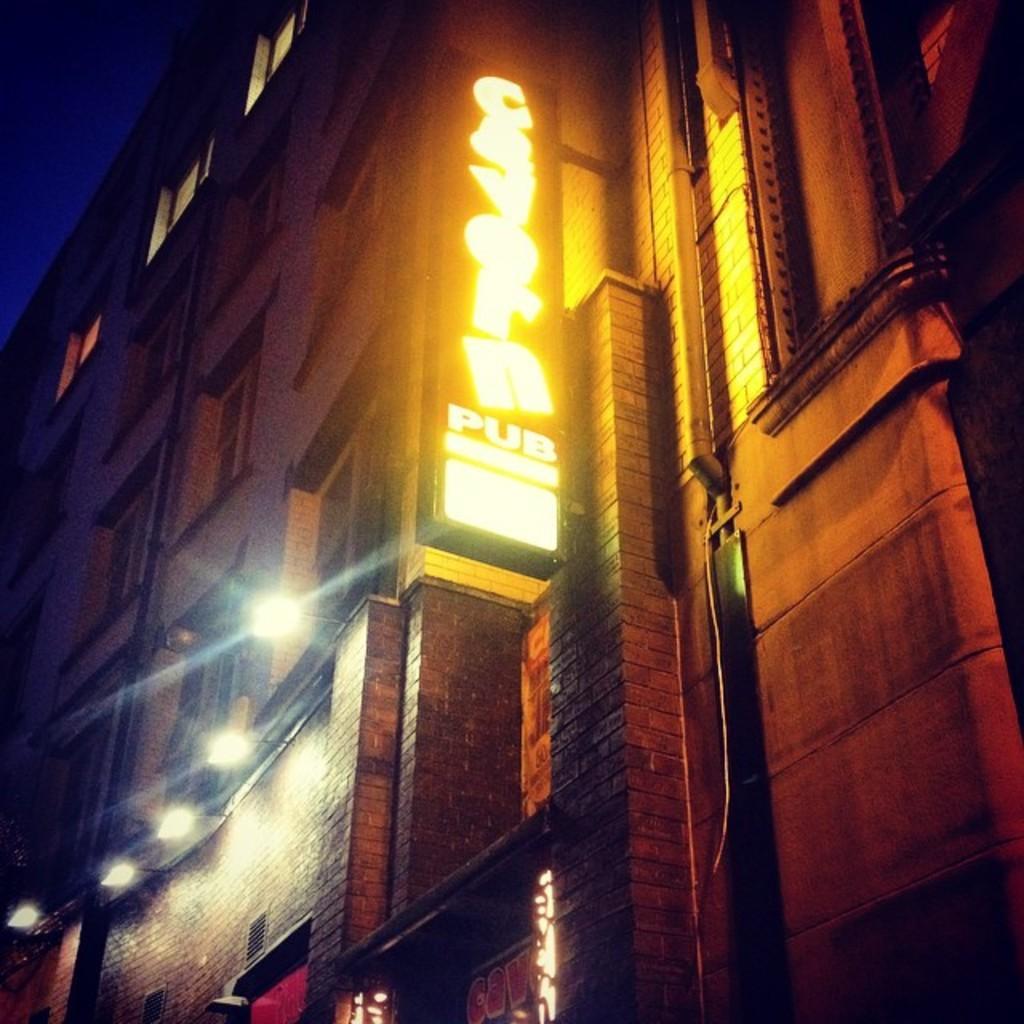Could you give a brief overview of what you see in this image? In the center of the image, we can see a building and there are lights and we can see a board with some text. 